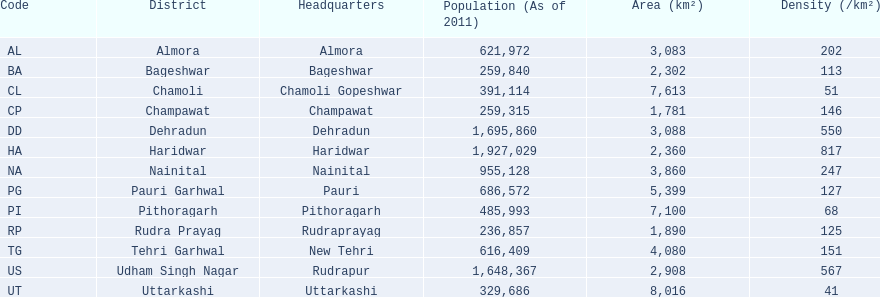What are the various district names? Almora, Bageshwar, Chamoli, Champawat, Dehradun, Haridwar, Nainital, Pauri Garhwal, Pithoragarh, Rudra Prayag, Tehri Garhwal, Udham Singh Nagar, Uttarkashi. What is the range of population densities within these districts? 202, 113, 51, 146, 550, 817, 247, 127, 68, 125, 151, 567, 41. Which district has a population density of 51? Chamoli. 